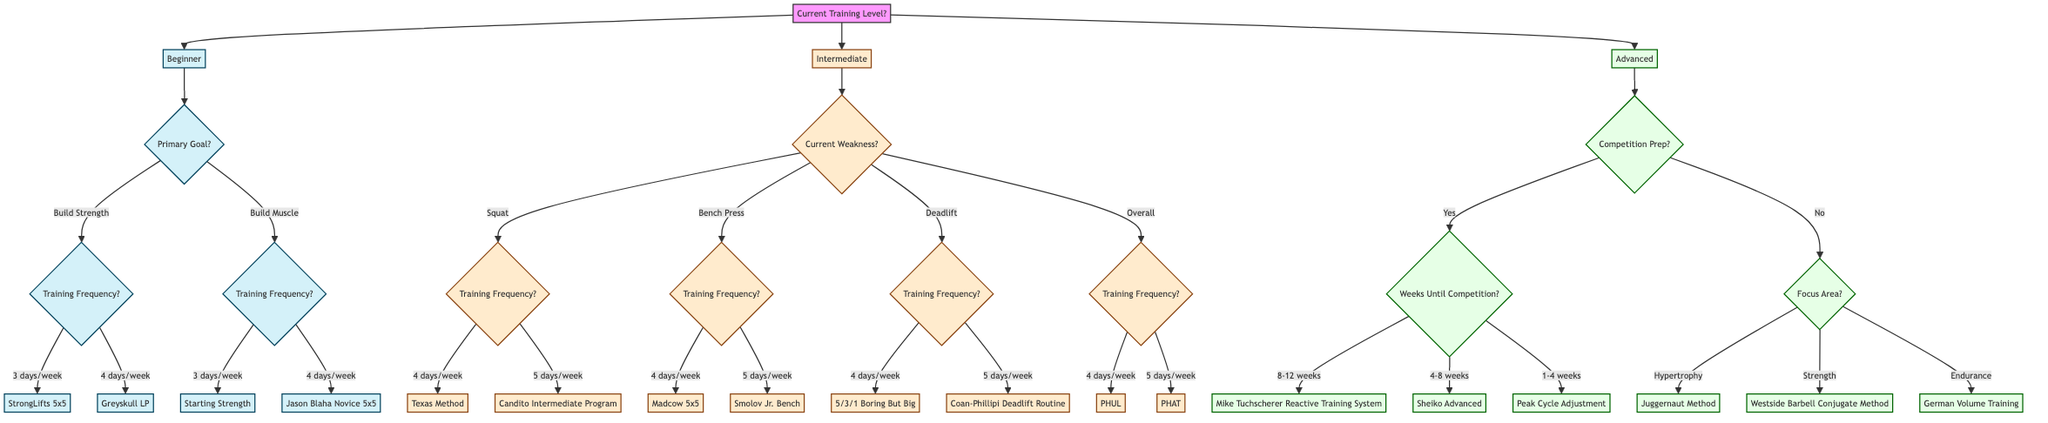What is the first question asked in the diagram? The first question posed to the user is about their "Current Training Level?" which starts the decision-making process in the diagram.
Answer: Current Training Level? How many primary goals can a beginner choose from? Looking at the node for beginners, there are two options listed under "Primary Goal?" which are "Build Strength" and "Build Muscle." Thus, there are two primary goals available.
Answer: 2 What training frequency options are available for an advanced lifter preparing for a competition? Under the "Competition Prep?" node for advanced lifters, there are three subsequent options for "Weeks Until Competition?" which create three different nodes, but each one does not specifically relate to training frequency. Instead, each leads to a specific regimen.
Answer: Not applicable If an intermediate lifter has a weakness in the deadlift, what are their training frequency choices? In the section for intermediate lifters, the branch for "Deadlift" under "Current Weakness?" presents two choices for "Training Frequency?": "4 days/week" and "5 days/week."
Answer: 4 days/week and 5 days/week Which training regimen is recommended for a beginner who wants to build strength and trains three days a week? Following the path from beginner to "Build Strength," then to the training frequency of "3 days/week," the regimen indicated at the end of that branch is "StrongLifts 5x5."
Answer: StrongLifts 5x5 What is the answer if an advanced lifter has more than eight weeks until their competition? For advanced lifters who respond "Yes" to "Competition Prep?" and choose "8-12 weeks" for "Weeks Until Competition?", the recommended regimen is "Mike Tuchscherer Reactive Training System."
Answer: Mike Tuchscherer Reactive Training System How many regimens are listed for lifters who do not have any competition preparations? In the section for advanced lifters who do not prepare for competitions, there are three focus area options ("Hypertrophy," "Strength," and "Endurance"). Each of those focus areas branches out to one regimen, but the direct count of regimens remains three.
Answer: 3 What is the training regimen recommended for an intermediate lifter with a weakness in the squat training four days a week? From the intermediate section, if the weakness is identified as "Squat" and the answer for frequency is "4 days/week," the resulting regimen is "Texas Method."
Answer: Texas Method 